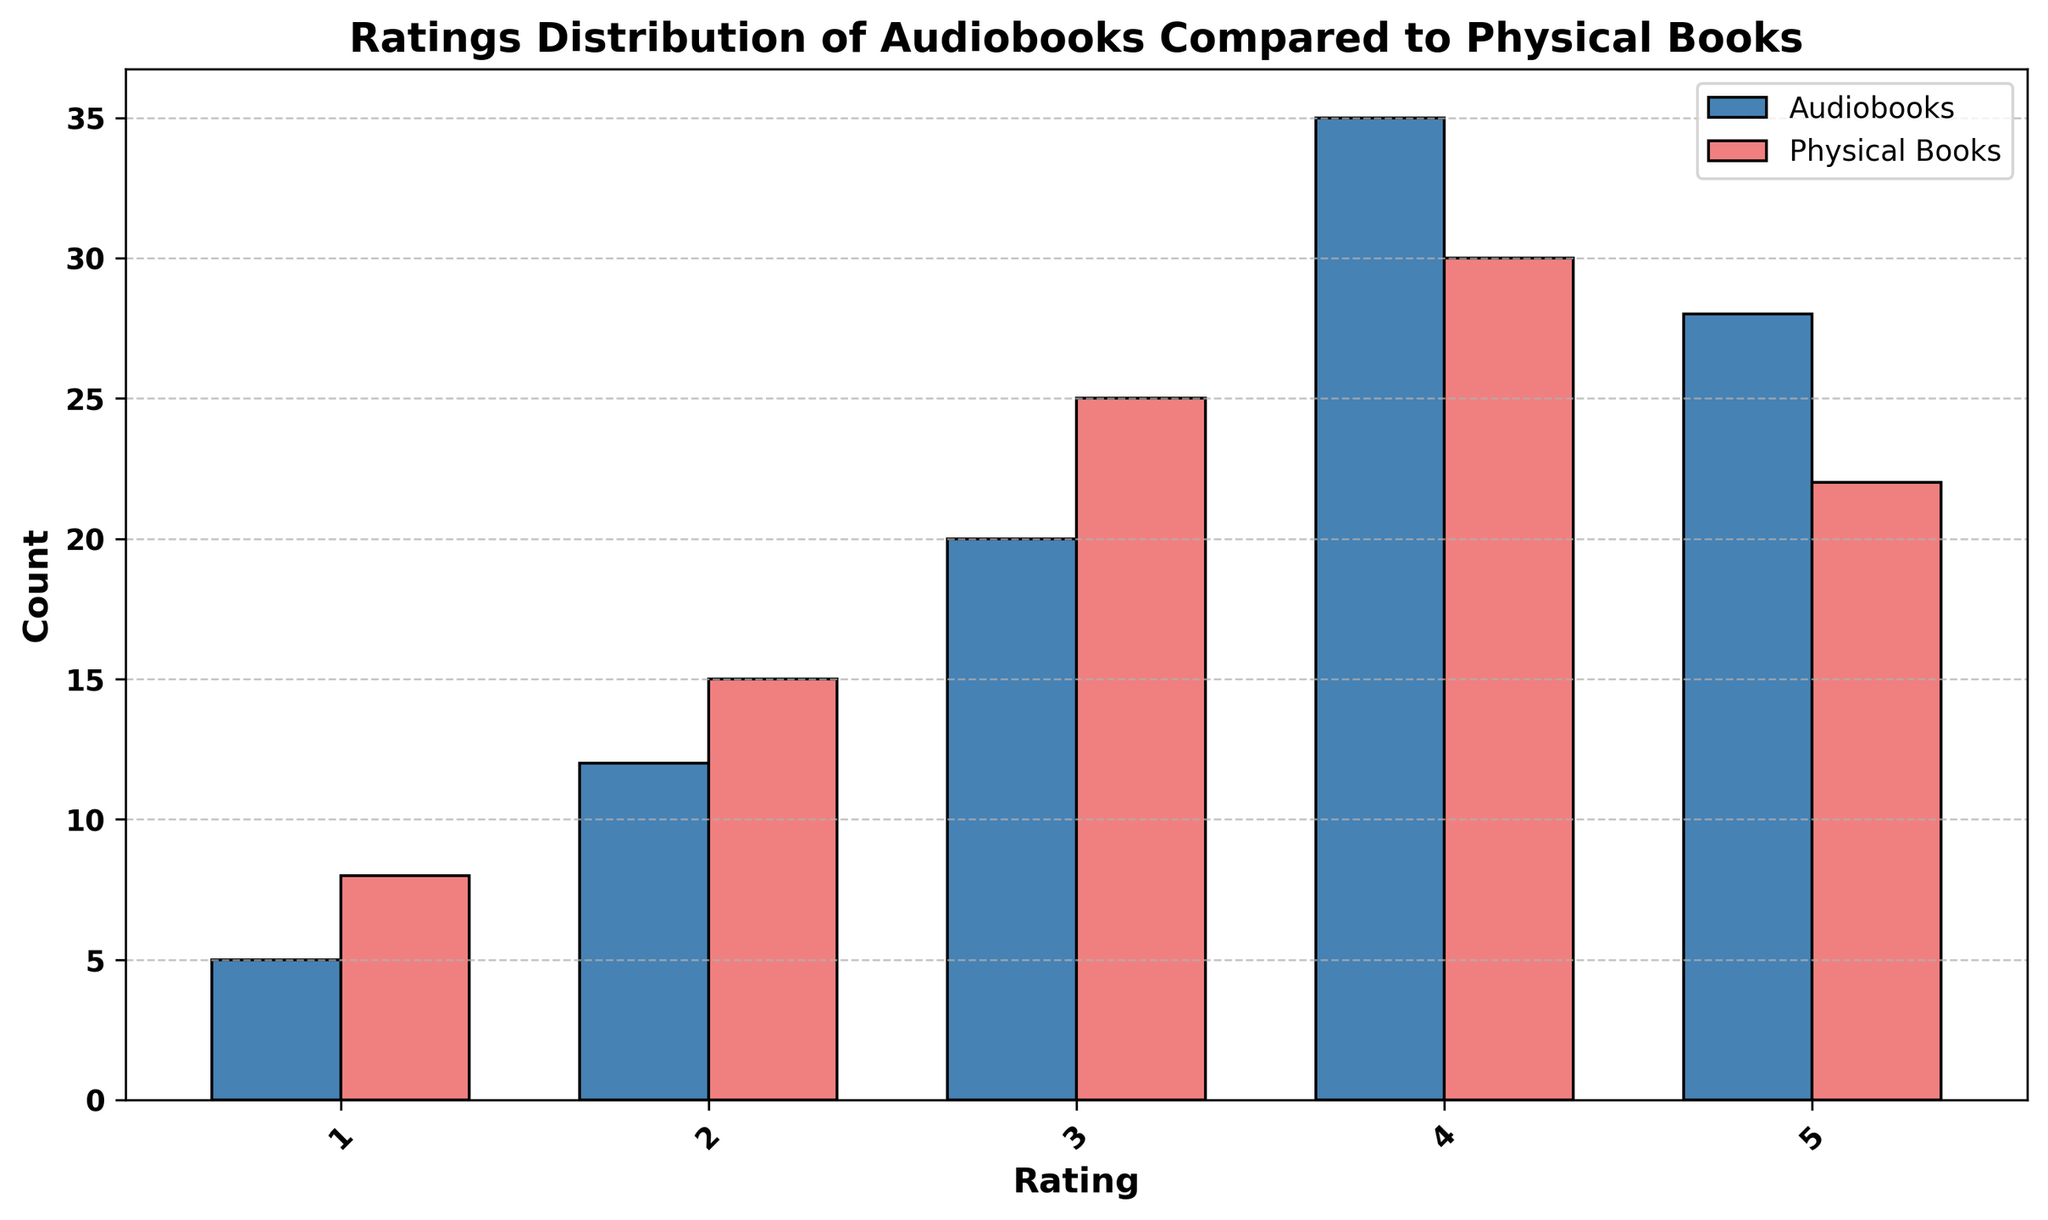What's the total count of 4-star and 5-star ratings for audiobooks? The count of 4-star ratings for audiobooks is 35, and the count of 5-star ratings for audiobooks is 28. Adding these together gives 35 + 28 = 63
Answer: 63 Which has more 3-star ratings, audiobooks or physical books? The height of the bar for 3-star ratings shows 20 for audiobooks and 25 for physical books. Since 25 > 20, physical books have more 3-star ratings.
Answer: Physical books What’s the difference in the count of 1-star ratings between audiobooks and physical books? The count of 1-star ratings for audiobooks is 5, and for physical books, it's 8. Calculating the difference, we get 8 - 5 = 3
Answer: 3 How does the count of the lowest-rated category for audiobooks compare to the highest-rated category for audiobooks? The lowest-rated category (1-star) for audiobooks has a count of 5, and the highest-rated category (4-star) has a count of 35. Comparing these, 35 is significantly higher than 5.
Answer: 4-star is significantly higher than 1-star Is the count of 2-star ratings higher or lower for audiobooks compared to physical books? The 2-star ratings for audiobooks is 12, while for physical books, it is 15. 12 < 15, so the count is lower for audiobooks.
Answer: Lower for audiobooks Which category has the highest overall count (both audiobooks and physical books combined), and what is that count? Adding both counts for each category: 1-star: 5+8=13, 2-star: 12+15=27, 3-star: 20+25=45, 4-star: 35+30=65, 5-star: 28+22=50. The 4-star category has the highest overall count of 65.
Answer: 4-star, 65 How many more 5-star ratings do audiobooks have compared to physical books? The count of 5-star ratings for audiobooks is 28, and for physical books, it is 22. The difference is 28 - 22 = 6.
Answer: 6 Are there more total ratings (summing all star categories) for audiobooks or for physical books? Summing the ratings for audiobooks (5 + 12 + 20 + 35 + 28) = 100 and for physical books (8 + 15 + 25 + 30 + 22) = 100. Both have equal total ratings of 100.
Answer: Equal In which rating category do physical books have a lower count compared to audiobooks? By observing each category: 
1-star: 8 vs 5 (physical books higher), 
2-star: 15 vs 12 (physical books higher),
3-star: 25 vs 20 (physical books higher), 
4-star: 30 vs 35 (physical books lower), 
5-star: 22 vs 28 (physical books lower). 
Physical books have lower counts in 4-star and 5-star categories.
Answer: 4-star and 5-star 